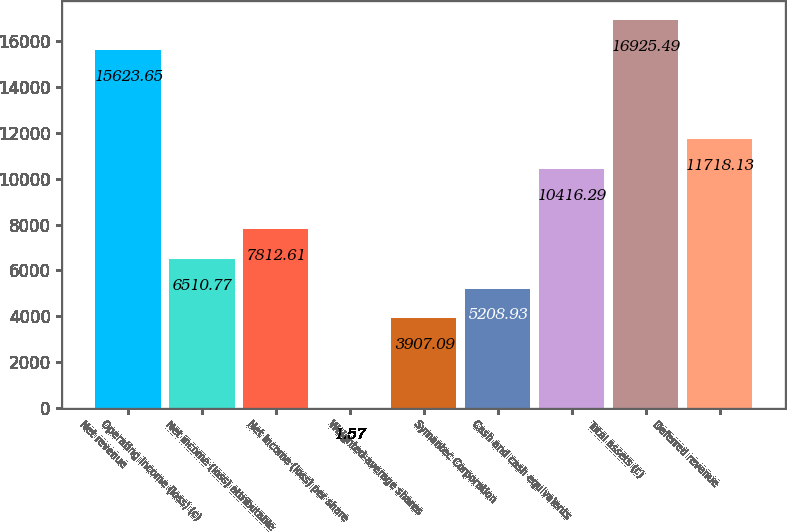<chart> <loc_0><loc_0><loc_500><loc_500><bar_chart><fcel>Net revenue<fcel>Operating income (loss) (c)<fcel>Net income (loss) attributable<fcel>Net income (loss) per share<fcel>Weighted-average shares<fcel>Symantec Corporation<fcel>Cash and cash equivalents<fcel>Total assets (c)<fcel>Deferred revenue<nl><fcel>15623.6<fcel>6510.77<fcel>7812.61<fcel>1.57<fcel>3907.09<fcel>5208.93<fcel>10416.3<fcel>16925.5<fcel>11718.1<nl></chart> 